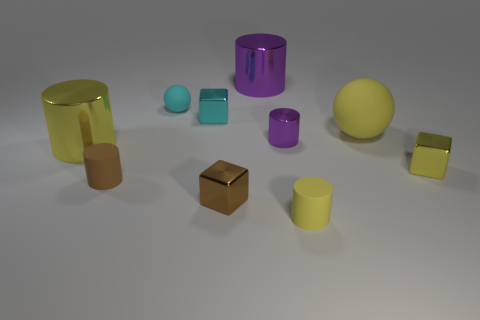Subtract all brown cylinders. How many cylinders are left? 4 Subtract 1 cylinders. How many cylinders are left? 4 Subtract all blue cylinders. Subtract all yellow balls. How many cylinders are left? 5 Subtract all blocks. How many objects are left? 7 Subtract all large yellow matte balls. Subtract all small cyan objects. How many objects are left? 7 Add 3 matte objects. How many matte objects are left? 7 Add 1 metal cylinders. How many metal cylinders exist? 4 Subtract 1 yellow cubes. How many objects are left? 9 